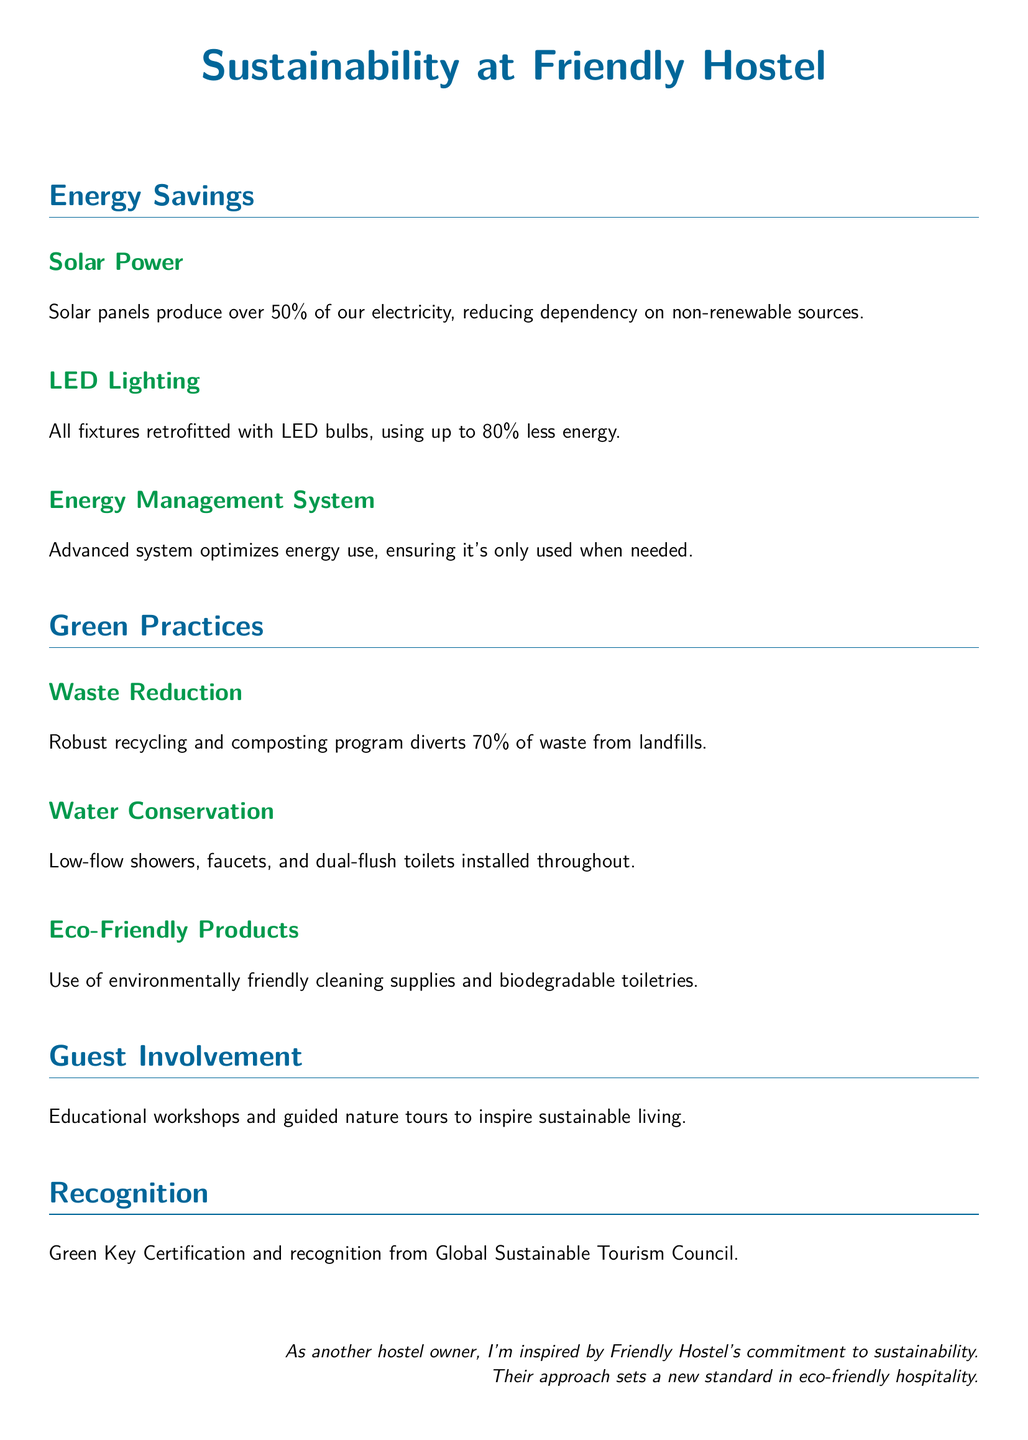What percentage of electricity is produced by solar panels? The document states that solar panels produce over 50% of the electricity at Friendly Hostel.
Answer: over 50% What energy-saving lighting technology has been implemented? The hostel has retrofitted all fixtures with LED bulbs, which use up to 80% less energy.
Answer: LED bulbs What is the waste diversion rate from landfills? The robust recycling and composting program diverts 70% of waste from landfills.
Answer: 70% What types of toilets have been installed for water conservation? The document mentions that dual-flush toilets have been installed throughout the hostel.
Answer: dual-flush toilets What certification has Friendly Hostel received? The hostel has received Green Key Certification as part of their sustainability efforts.
Answer: Green Key Certification How does the Energy Management System benefit the hostel? It optimizes energy use, ensuring energy is only used when needed.
Answer: optimizes energy use What type of workshops does Friendly Hostel offer? The hostel offers educational workshops to inspire sustainable living among guests.
Answer: educational workshops What color is used for section titles in the Playbill? The section titles are colored ecoblue in the document.
Answer: ecoblue 